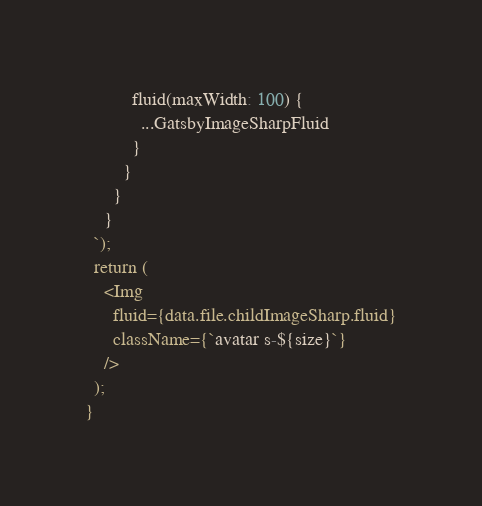<code> <loc_0><loc_0><loc_500><loc_500><_JavaScript_>          fluid(maxWidth: 100) {
            ...GatsbyImageSharpFluid
          }
        }
      }
    }
  `);
  return (
    <Img
      fluid={data.file.childImageSharp.fluid}
      className={`avatar s-${size}`}
    />
  );
}
</code> 